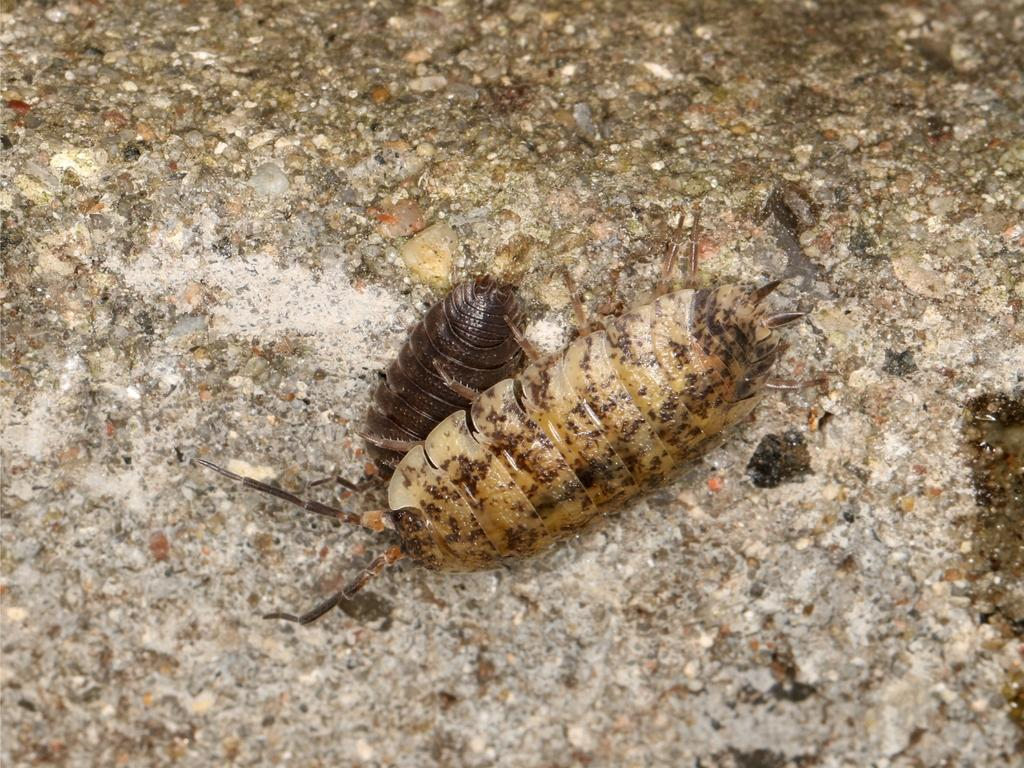What type of creatures can be seen in the image? There are insects in the image. What can be seen in the background of the image? There is a rock in the background of the image. What type of skin can be seen on the insects in the image? The insects in the image do not have skin; they have exoskeletons. What design is featured on the pen in the image? There is no pen present in the image. 